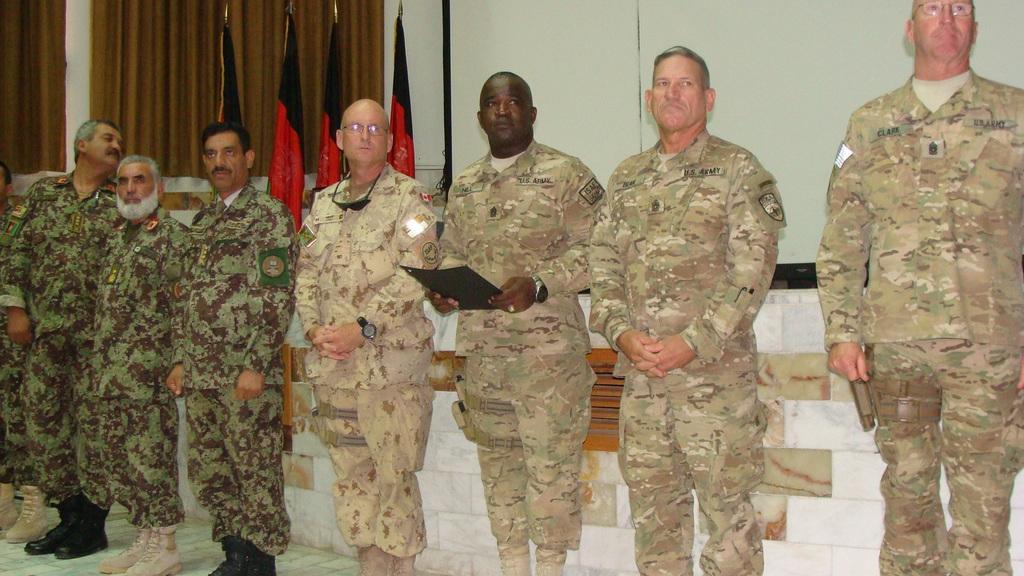Please provide a concise description of this image. There are people standing and this person holding file. Background we can see wall,flags and curtains. 